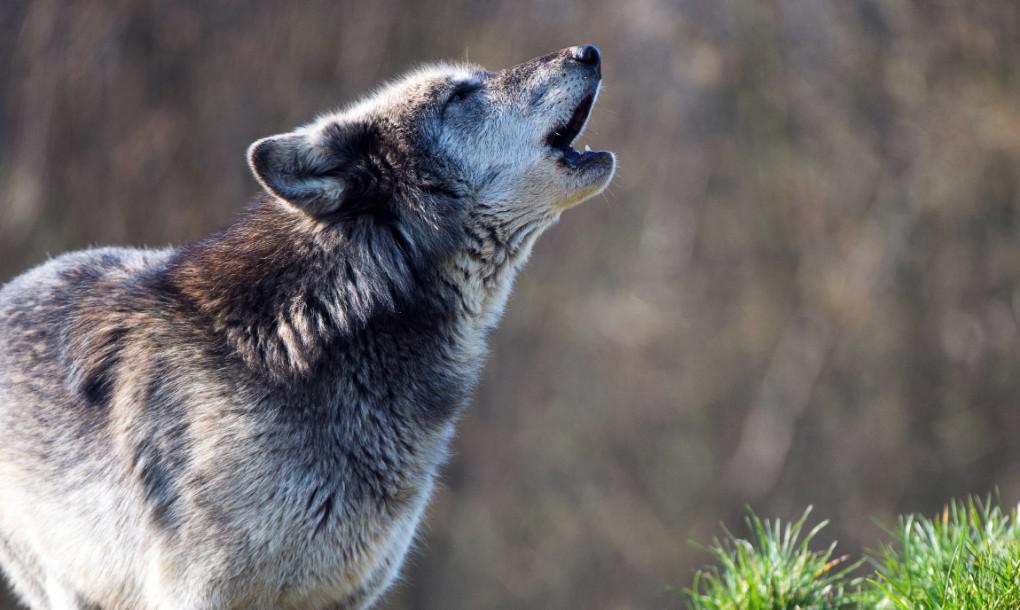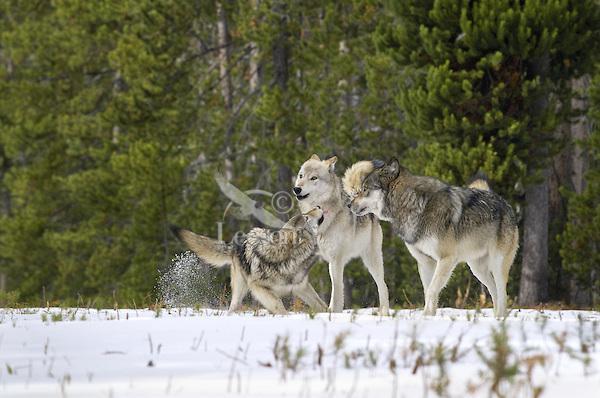The first image is the image on the left, the second image is the image on the right. Considering the images on both sides, is "The right image contains three wolves in the snow." valid? Answer yes or no. Yes. The first image is the image on the left, the second image is the image on the right. For the images shown, is this caption "The animals in the image on the right are in the snow." true? Answer yes or no. Yes. 